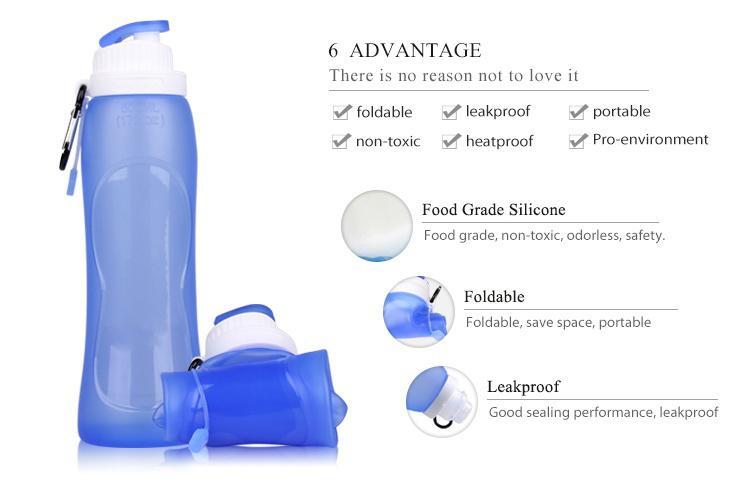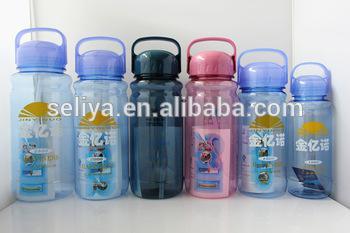The first image is the image on the left, the second image is the image on the right. Given the left and right images, does the statement "The right image contains exactly three bottle containers arranged in a horizontal row." hold true? Answer yes or no. No. 